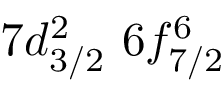Convert formula to latex. <formula><loc_0><loc_0><loc_500><loc_500>7 d _ { 3 / 2 } ^ { 2 } \, 6 f _ { 7 / 2 } ^ { 6 }</formula> 